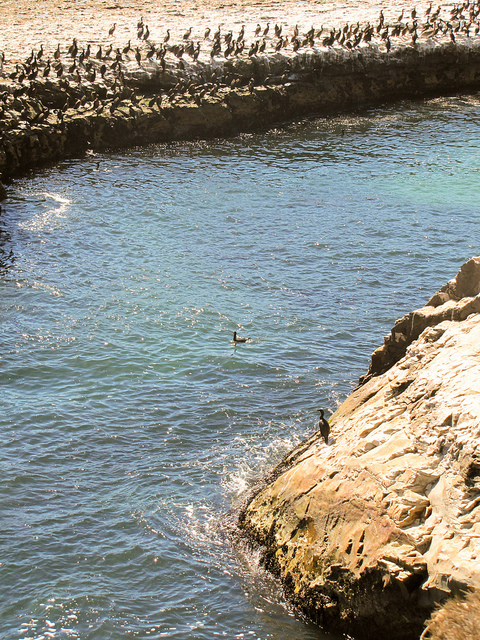What surface are all the birds standing on next to the big river?
A. wood
B. grass
C. stone
D. dirt
Answer with the option's letter from the given choices directly. C What is usually found inside of the large blue item?
A. beef
B. fish
C. flowers
D. soda B 